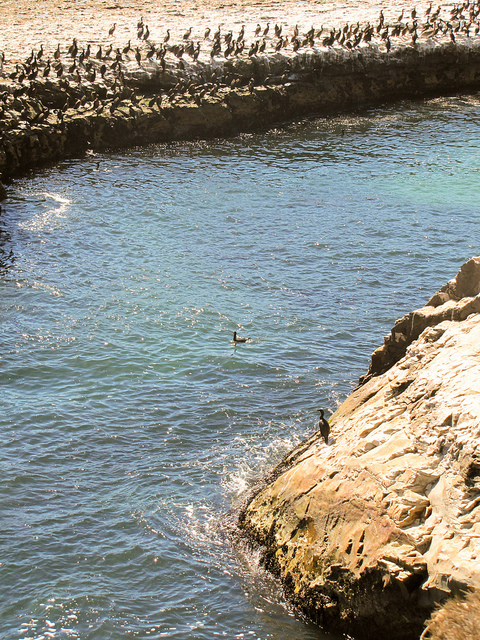What surface are all the birds standing on next to the big river?
A. wood
B. grass
C. stone
D. dirt
Answer with the option's letter from the given choices directly. C What is usually found inside of the large blue item?
A. beef
B. fish
C. flowers
D. soda B 